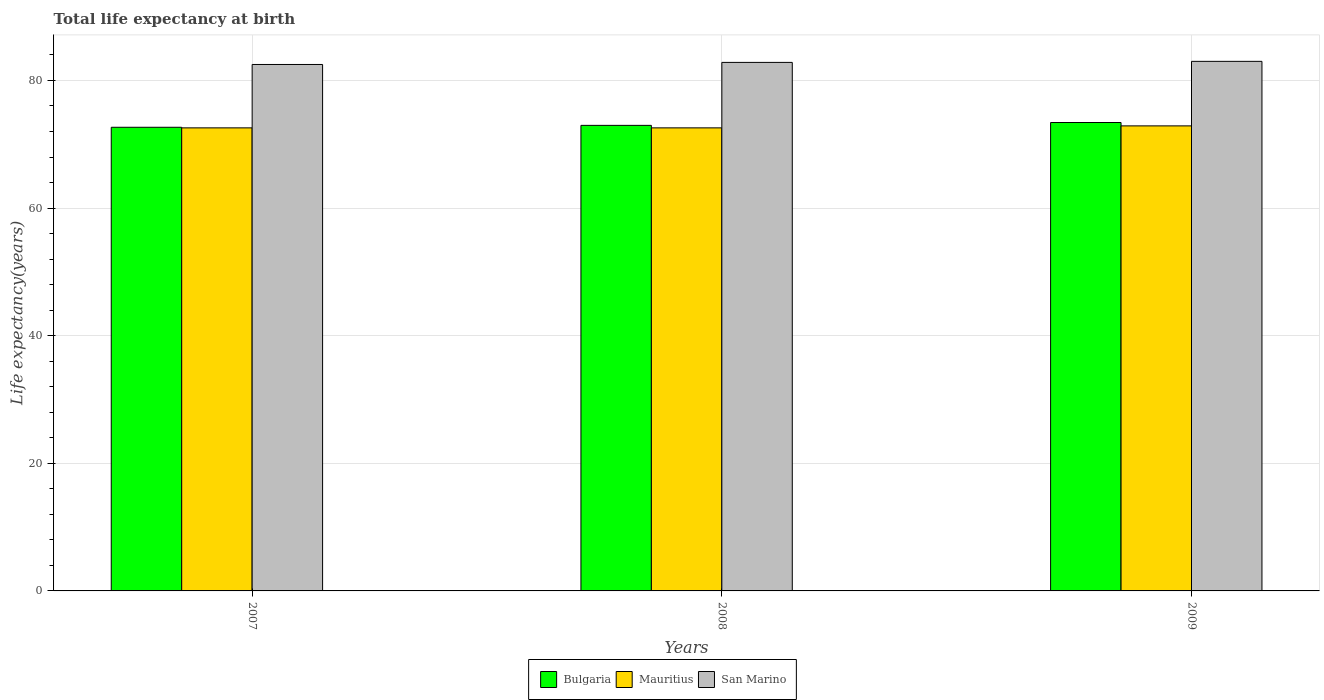How many different coloured bars are there?
Your response must be concise. 3. Are the number of bars on each tick of the X-axis equal?
Provide a succinct answer. Yes. How many bars are there on the 1st tick from the right?
Offer a very short reply. 3. What is the life expectancy at birth in in Mauritius in 2008?
Keep it short and to the point. 72.57. Across all years, what is the maximum life expectancy at birth in in Bulgaria?
Provide a succinct answer. 73.41. Across all years, what is the minimum life expectancy at birth in in Bulgaria?
Your answer should be compact. 72.66. In which year was the life expectancy at birth in in Bulgaria maximum?
Provide a succinct answer. 2009. What is the total life expectancy at birth in in San Marino in the graph?
Provide a succinct answer. 248.33. What is the difference between the life expectancy at birth in in Mauritius in 2007 and that in 2009?
Provide a short and direct response. -0.31. What is the difference between the life expectancy at birth in in Bulgaria in 2008 and the life expectancy at birth in in Mauritius in 2009?
Keep it short and to the point. 0.08. What is the average life expectancy at birth in in Mauritius per year?
Provide a short and direct response. 72.67. In the year 2009, what is the difference between the life expectancy at birth in in Bulgaria and life expectancy at birth in in San Marino?
Offer a very short reply. -9.58. What is the ratio of the life expectancy at birth in in San Marino in 2008 to that in 2009?
Provide a short and direct response. 1. What is the difference between the highest and the second highest life expectancy at birth in in San Marino?
Your answer should be compact. 0.16. What is the difference between the highest and the lowest life expectancy at birth in in San Marino?
Offer a very short reply. 0.49. In how many years, is the life expectancy at birth in in Mauritius greater than the average life expectancy at birth in in Mauritius taken over all years?
Provide a short and direct response. 1. What does the 3rd bar from the left in 2009 represents?
Your answer should be compact. San Marino. Is it the case that in every year, the sum of the life expectancy at birth in in Bulgaria and life expectancy at birth in in Mauritius is greater than the life expectancy at birth in in San Marino?
Ensure brevity in your answer.  Yes. How many bars are there?
Make the answer very short. 9. How many years are there in the graph?
Offer a very short reply. 3. Are the values on the major ticks of Y-axis written in scientific E-notation?
Your response must be concise. No. Where does the legend appear in the graph?
Give a very brief answer. Bottom center. How many legend labels are there?
Keep it short and to the point. 3. What is the title of the graph?
Your response must be concise. Total life expectancy at birth. Does "Maldives" appear as one of the legend labels in the graph?
Keep it short and to the point. No. What is the label or title of the Y-axis?
Make the answer very short. Life expectancy(years). What is the Life expectancy(years) in Bulgaria in 2007?
Your answer should be compact. 72.66. What is the Life expectancy(years) of Mauritius in 2007?
Make the answer very short. 72.57. What is the Life expectancy(years) in San Marino in 2007?
Provide a succinct answer. 82.51. What is the Life expectancy(years) of Bulgaria in 2008?
Make the answer very short. 72.96. What is the Life expectancy(years) of Mauritius in 2008?
Your response must be concise. 72.57. What is the Life expectancy(years) in San Marino in 2008?
Offer a terse response. 82.83. What is the Life expectancy(years) of Bulgaria in 2009?
Offer a terse response. 73.41. What is the Life expectancy(years) in Mauritius in 2009?
Ensure brevity in your answer.  72.88. What is the Life expectancy(years) in San Marino in 2009?
Your answer should be very brief. 83. Across all years, what is the maximum Life expectancy(years) of Bulgaria?
Your response must be concise. 73.41. Across all years, what is the maximum Life expectancy(years) in Mauritius?
Provide a succinct answer. 72.88. Across all years, what is the maximum Life expectancy(years) of San Marino?
Your response must be concise. 83. Across all years, what is the minimum Life expectancy(years) of Bulgaria?
Your response must be concise. 72.66. Across all years, what is the minimum Life expectancy(years) in Mauritius?
Make the answer very short. 72.57. Across all years, what is the minimum Life expectancy(years) of San Marino?
Your answer should be compact. 82.51. What is the total Life expectancy(years) in Bulgaria in the graph?
Give a very brief answer. 219.04. What is the total Life expectancy(years) of Mauritius in the graph?
Your answer should be compact. 218.02. What is the total Life expectancy(years) of San Marino in the graph?
Your response must be concise. 248.33. What is the difference between the Life expectancy(years) in Mauritius in 2007 and that in 2008?
Provide a short and direct response. 0. What is the difference between the Life expectancy(years) of San Marino in 2007 and that in 2008?
Your answer should be compact. -0.33. What is the difference between the Life expectancy(years) of Bulgaria in 2007 and that in 2009?
Give a very brief answer. -0.75. What is the difference between the Life expectancy(years) of Mauritius in 2007 and that in 2009?
Provide a succinct answer. -0.31. What is the difference between the Life expectancy(years) in San Marino in 2007 and that in 2009?
Ensure brevity in your answer.  -0.49. What is the difference between the Life expectancy(years) in Bulgaria in 2008 and that in 2009?
Your answer should be compact. -0.45. What is the difference between the Life expectancy(years) in Mauritius in 2008 and that in 2009?
Keep it short and to the point. -0.31. What is the difference between the Life expectancy(years) of San Marino in 2008 and that in 2009?
Ensure brevity in your answer.  -0.16. What is the difference between the Life expectancy(years) of Bulgaria in 2007 and the Life expectancy(years) of Mauritius in 2008?
Your answer should be compact. 0.09. What is the difference between the Life expectancy(years) of Bulgaria in 2007 and the Life expectancy(years) of San Marino in 2008?
Provide a short and direct response. -10.17. What is the difference between the Life expectancy(years) in Mauritius in 2007 and the Life expectancy(years) in San Marino in 2008?
Your answer should be compact. -10.26. What is the difference between the Life expectancy(years) in Bulgaria in 2007 and the Life expectancy(years) in Mauritius in 2009?
Make the answer very short. -0.22. What is the difference between the Life expectancy(years) of Bulgaria in 2007 and the Life expectancy(years) of San Marino in 2009?
Provide a short and direct response. -10.33. What is the difference between the Life expectancy(years) of Mauritius in 2007 and the Life expectancy(years) of San Marino in 2009?
Your response must be concise. -10.42. What is the difference between the Life expectancy(years) of Bulgaria in 2008 and the Life expectancy(years) of Mauritius in 2009?
Offer a terse response. 0.08. What is the difference between the Life expectancy(years) of Bulgaria in 2008 and the Life expectancy(years) of San Marino in 2009?
Your answer should be compact. -10.03. What is the difference between the Life expectancy(years) in Mauritius in 2008 and the Life expectancy(years) in San Marino in 2009?
Give a very brief answer. -10.42. What is the average Life expectancy(years) in Bulgaria per year?
Offer a terse response. 73.01. What is the average Life expectancy(years) of Mauritius per year?
Offer a terse response. 72.67. What is the average Life expectancy(years) of San Marino per year?
Offer a terse response. 82.78. In the year 2007, what is the difference between the Life expectancy(years) of Bulgaria and Life expectancy(years) of Mauritius?
Offer a terse response. 0.09. In the year 2007, what is the difference between the Life expectancy(years) of Bulgaria and Life expectancy(years) of San Marino?
Your answer should be very brief. -9.84. In the year 2007, what is the difference between the Life expectancy(years) of Mauritius and Life expectancy(years) of San Marino?
Your response must be concise. -9.94. In the year 2008, what is the difference between the Life expectancy(years) of Bulgaria and Life expectancy(years) of Mauritius?
Keep it short and to the point. 0.39. In the year 2008, what is the difference between the Life expectancy(years) in Bulgaria and Life expectancy(years) in San Marino?
Provide a short and direct response. -9.87. In the year 2008, what is the difference between the Life expectancy(years) of Mauritius and Life expectancy(years) of San Marino?
Your response must be concise. -10.26. In the year 2009, what is the difference between the Life expectancy(years) of Bulgaria and Life expectancy(years) of Mauritius?
Ensure brevity in your answer.  0.53. In the year 2009, what is the difference between the Life expectancy(years) of Bulgaria and Life expectancy(years) of San Marino?
Offer a very short reply. -9.58. In the year 2009, what is the difference between the Life expectancy(years) in Mauritius and Life expectancy(years) in San Marino?
Keep it short and to the point. -10.11. What is the ratio of the Life expectancy(years) in Bulgaria in 2007 to that in 2008?
Provide a succinct answer. 1. What is the ratio of the Life expectancy(years) in San Marino in 2007 to that in 2008?
Your response must be concise. 1. What is the ratio of the Life expectancy(years) of Bulgaria in 2007 to that in 2009?
Ensure brevity in your answer.  0.99. What is the ratio of the Life expectancy(years) in Mauritius in 2007 to that in 2009?
Provide a short and direct response. 1. What is the ratio of the Life expectancy(years) of San Marino in 2007 to that in 2009?
Your response must be concise. 0.99. What is the ratio of the Life expectancy(years) in Bulgaria in 2008 to that in 2009?
Your answer should be very brief. 0.99. What is the difference between the highest and the second highest Life expectancy(years) of Bulgaria?
Offer a terse response. 0.45. What is the difference between the highest and the second highest Life expectancy(years) of Mauritius?
Your answer should be very brief. 0.31. What is the difference between the highest and the second highest Life expectancy(years) of San Marino?
Your answer should be compact. 0.16. What is the difference between the highest and the lowest Life expectancy(years) of Bulgaria?
Provide a succinct answer. 0.75. What is the difference between the highest and the lowest Life expectancy(years) in Mauritius?
Keep it short and to the point. 0.31. What is the difference between the highest and the lowest Life expectancy(years) in San Marino?
Provide a short and direct response. 0.49. 